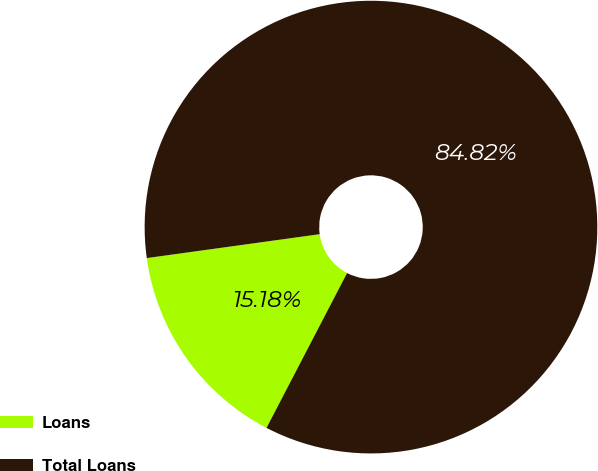Convert chart. <chart><loc_0><loc_0><loc_500><loc_500><pie_chart><fcel>Loans<fcel>Total Loans<nl><fcel>15.18%<fcel>84.82%<nl></chart> 